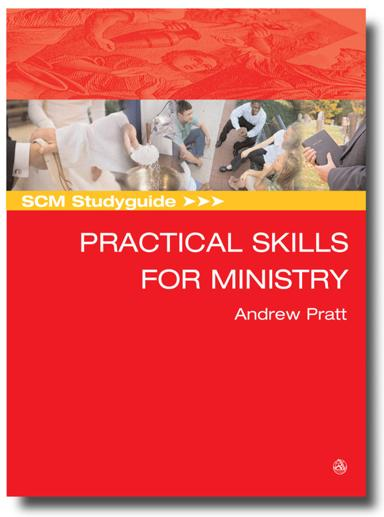Aside from the title and author, are there any other texts or symbols on the cover that convey more about this guide's purpose? Apart from the title and author's name, the book cover includes an SCM Studyguide logo at the bottom right, indicating that it is part of a well-regarded educational series. The images on the cover, showcasing diverse groups engaging in discussion and activities, visually suggest group learning and active participation, important aspects of practical ministry training. 